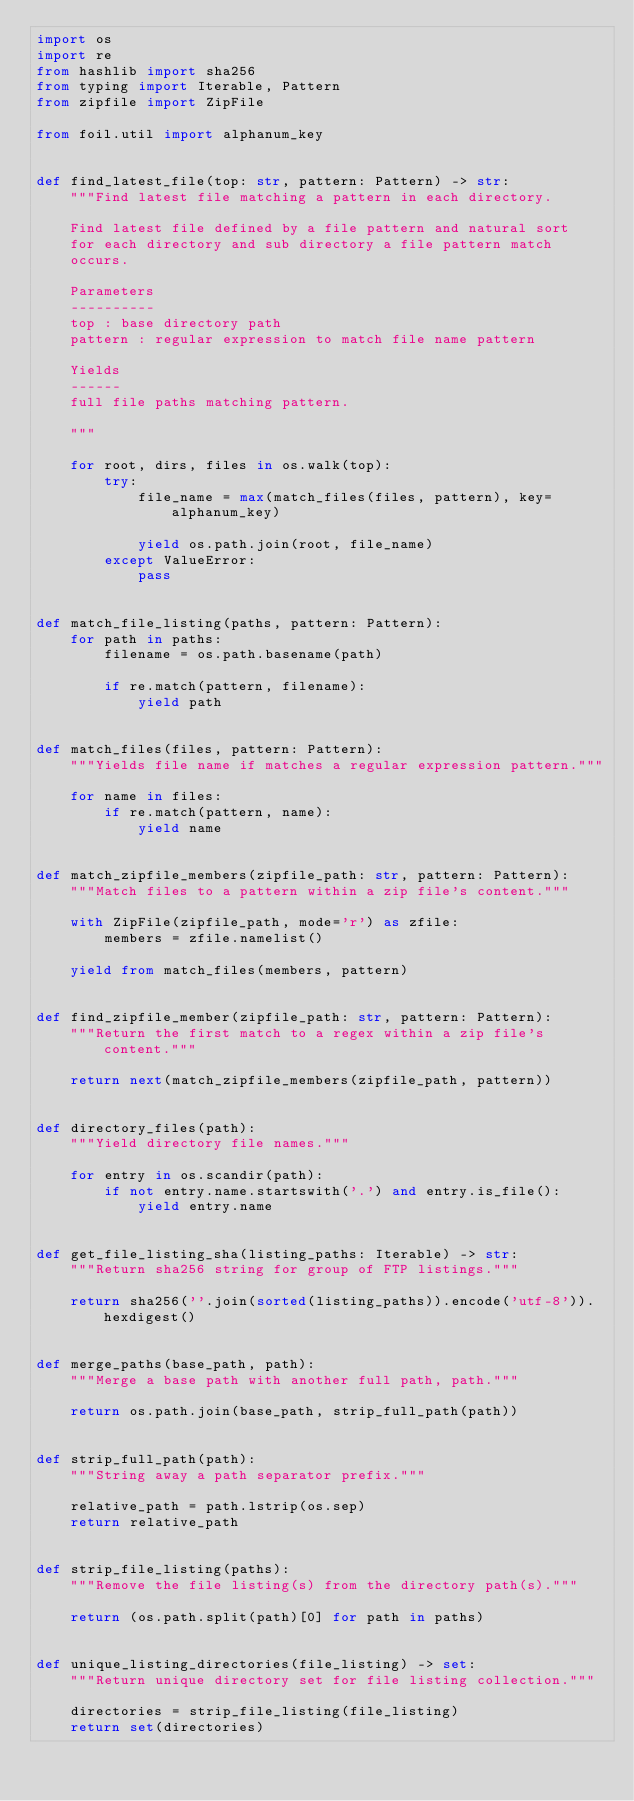<code> <loc_0><loc_0><loc_500><loc_500><_Python_>import os
import re
from hashlib import sha256
from typing import Iterable, Pattern
from zipfile import ZipFile

from foil.util import alphanum_key


def find_latest_file(top: str, pattern: Pattern) -> str:
    """Find latest file matching a pattern in each directory.

    Find latest file defined by a file pattern and natural sort
    for each directory and sub directory a file pattern match
    occurs.

    Parameters
    ----------
    top : base directory path
    pattern : regular expression to match file name pattern

    Yields
    ------
    full file paths matching pattern.

    """

    for root, dirs, files in os.walk(top):
        try:
            file_name = max(match_files(files, pattern), key=alphanum_key)

            yield os.path.join(root, file_name)
        except ValueError:
            pass


def match_file_listing(paths, pattern: Pattern):
    for path in paths:
        filename = os.path.basename(path)

        if re.match(pattern, filename):
            yield path


def match_files(files, pattern: Pattern):
    """Yields file name if matches a regular expression pattern."""

    for name in files:
        if re.match(pattern, name):
            yield name


def match_zipfile_members(zipfile_path: str, pattern: Pattern):
    """Match files to a pattern within a zip file's content."""

    with ZipFile(zipfile_path, mode='r') as zfile:
        members = zfile.namelist()

    yield from match_files(members, pattern)


def find_zipfile_member(zipfile_path: str, pattern: Pattern):
    """Return the first match to a regex within a zip file's content."""

    return next(match_zipfile_members(zipfile_path, pattern))


def directory_files(path):
    """Yield directory file names."""

    for entry in os.scandir(path):
        if not entry.name.startswith('.') and entry.is_file():
            yield entry.name


def get_file_listing_sha(listing_paths: Iterable) -> str:
    """Return sha256 string for group of FTP listings."""

    return sha256(''.join(sorted(listing_paths)).encode('utf-8')).hexdigest()


def merge_paths(base_path, path):
    """Merge a base path with another full path, path."""

    return os.path.join(base_path, strip_full_path(path))


def strip_full_path(path):
    """String away a path separator prefix."""

    relative_path = path.lstrip(os.sep)
    return relative_path


def strip_file_listing(paths):
    """Remove the file listing(s) from the directory path(s)."""

    return (os.path.split(path)[0] for path in paths)


def unique_listing_directories(file_listing) -> set:
    """Return unique directory set for file listing collection."""

    directories = strip_file_listing(file_listing)
    return set(directories)
</code> 